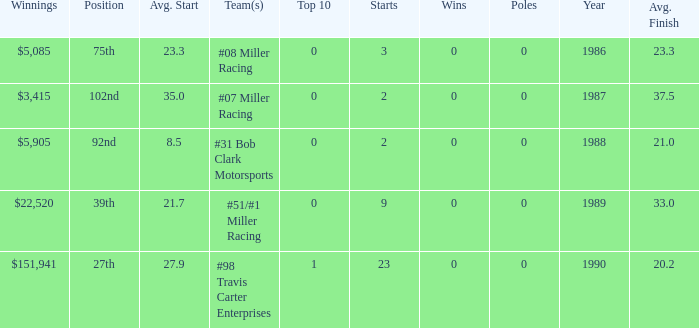What is the most recent year where the average start is 8.5? 1988.0. 